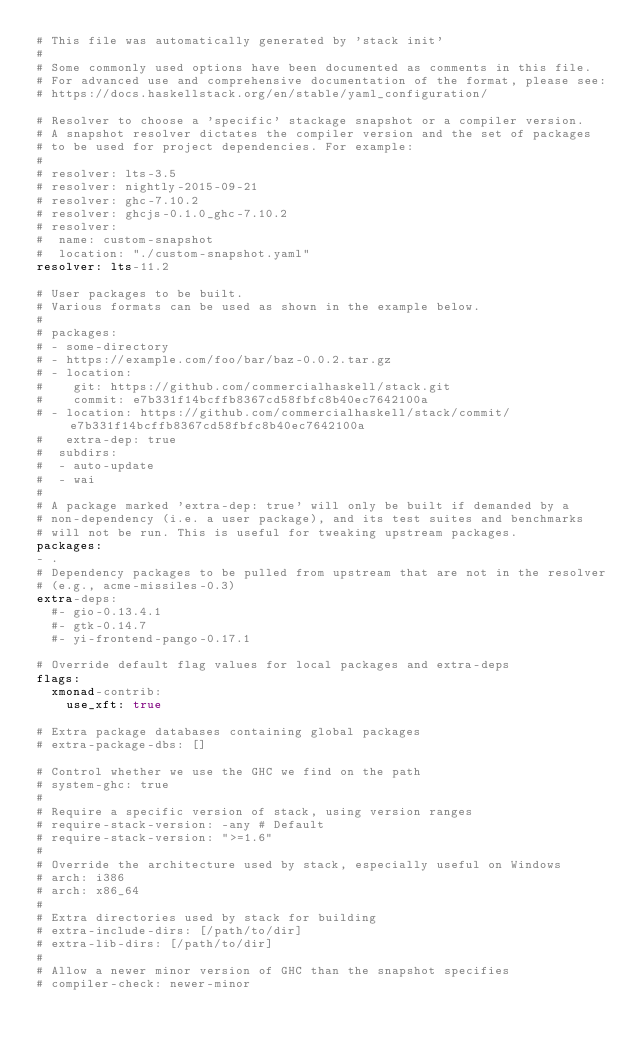<code> <loc_0><loc_0><loc_500><loc_500><_YAML_># This file was automatically generated by 'stack init'
#
# Some commonly used options have been documented as comments in this file.
# For advanced use and comprehensive documentation of the format, please see:
# https://docs.haskellstack.org/en/stable/yaml_configuration/

# Resolver to choose a 'specific' stackage snapshot or a compiler version.
# A snapshot resolver dictates the compiler version and the set of packages
# to be used for project dependencies. For example:
#
# resolver: lts-3.5
# resolver: nightly-2015-09-21
# resolver: ghc-7.10.2
# resolver: ghcjs-0.1.0_ghc-7.10.2
# resolver:
#  name: custom-snapshot
#  location: "./custom-snapshot.yaml"
resolver: lts-11.2

# User packages to be built.
# Various formats can be used as shown in the example below.
#
# packages:
# - some-directory
# - https://example.com/foo/bar/baz-0.0.2.tar.gz
# - location:
#    git: https://github.com/commercialhaskell/stack.git
#    commit: e7b331f14bcffb8367cd58fbfc8b40ec7642100a
# - location: https://github.com/commercialhaskell/stack/commit/e7b331f14bcffb8367cd58fbfc8b40ec7642100a
#   extra-dep: true
#  subdirs:
#  - auto-update
#  - wai
#
# A package marked 'extra-dep: true' will only be built if demanded by a
# non-dependency (i.e. a user package), and its test suites and benchmarks
# will not be run. This is useful for tweaking upstream packages.
packages:
- .
# Dependency packages to be pulled from upstream that are not in the resolver
# (e.g., acme-missiles-0.3)
extra-deps:
  #- gio-0.13.4.1
  #- gtk-0.14.7
  #- yi-frontend-pango-0.17.1

# Override default flag values for local packages and extra-deps
flags:
  xmonad-contrib:
    use_xft: true

# Extra package databases containing global packages
# extra-package-dbs: []

# Control whether we use the GHC we find on the path
# system-ghc: true
#
# Require a specific version of stack, using version ranges
# require-stack-version: -any # Default
# require-stack-version: ">=1.6"
#
# Override the architecture used by stack, especially useful on Windows
# arch: i386
# arch: x86_64
#
# Extra directories used by stack for building
# extra-include-dirs: [/path/to/dir]
# extra-lib-dirs: [/path/to/dir]
#
# Allow a newer minor version of GHC than the snapshot specifies
# compiler-check: newer-minor
</code> 